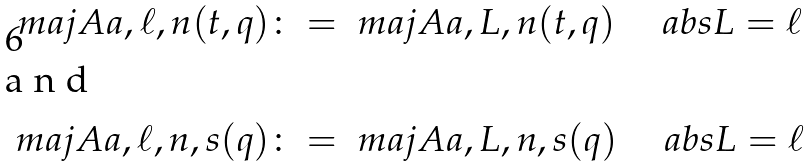Convert formula to latex. <formula><loc_0><loc_0><loc_500><loc_500>\ m a j A { a , \ell , n } ( t , q ) & \colon = \ m a j A { a , L , n } ( t , q ) \quad \ a b s { L } = \ell \\ \intertext { a n d } \ m a j A { a , \ell , n , s } ( q ) & \colon = \ m a j A { a , L , n , s } ( q ) \quad \ a b s { L } = \ell</formula> 